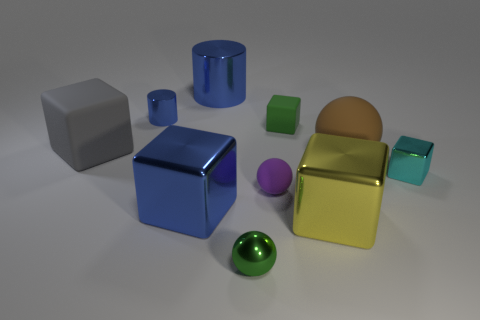Can you describe the material properties of the objects in the image? The objects in the image appear to be rendered with a variety of material finishes. They include matte, polished, and possibly metallic textures that reflect light to varying degrees, suggesting they are made from different materials like plastic, metal, or even ceramic. 